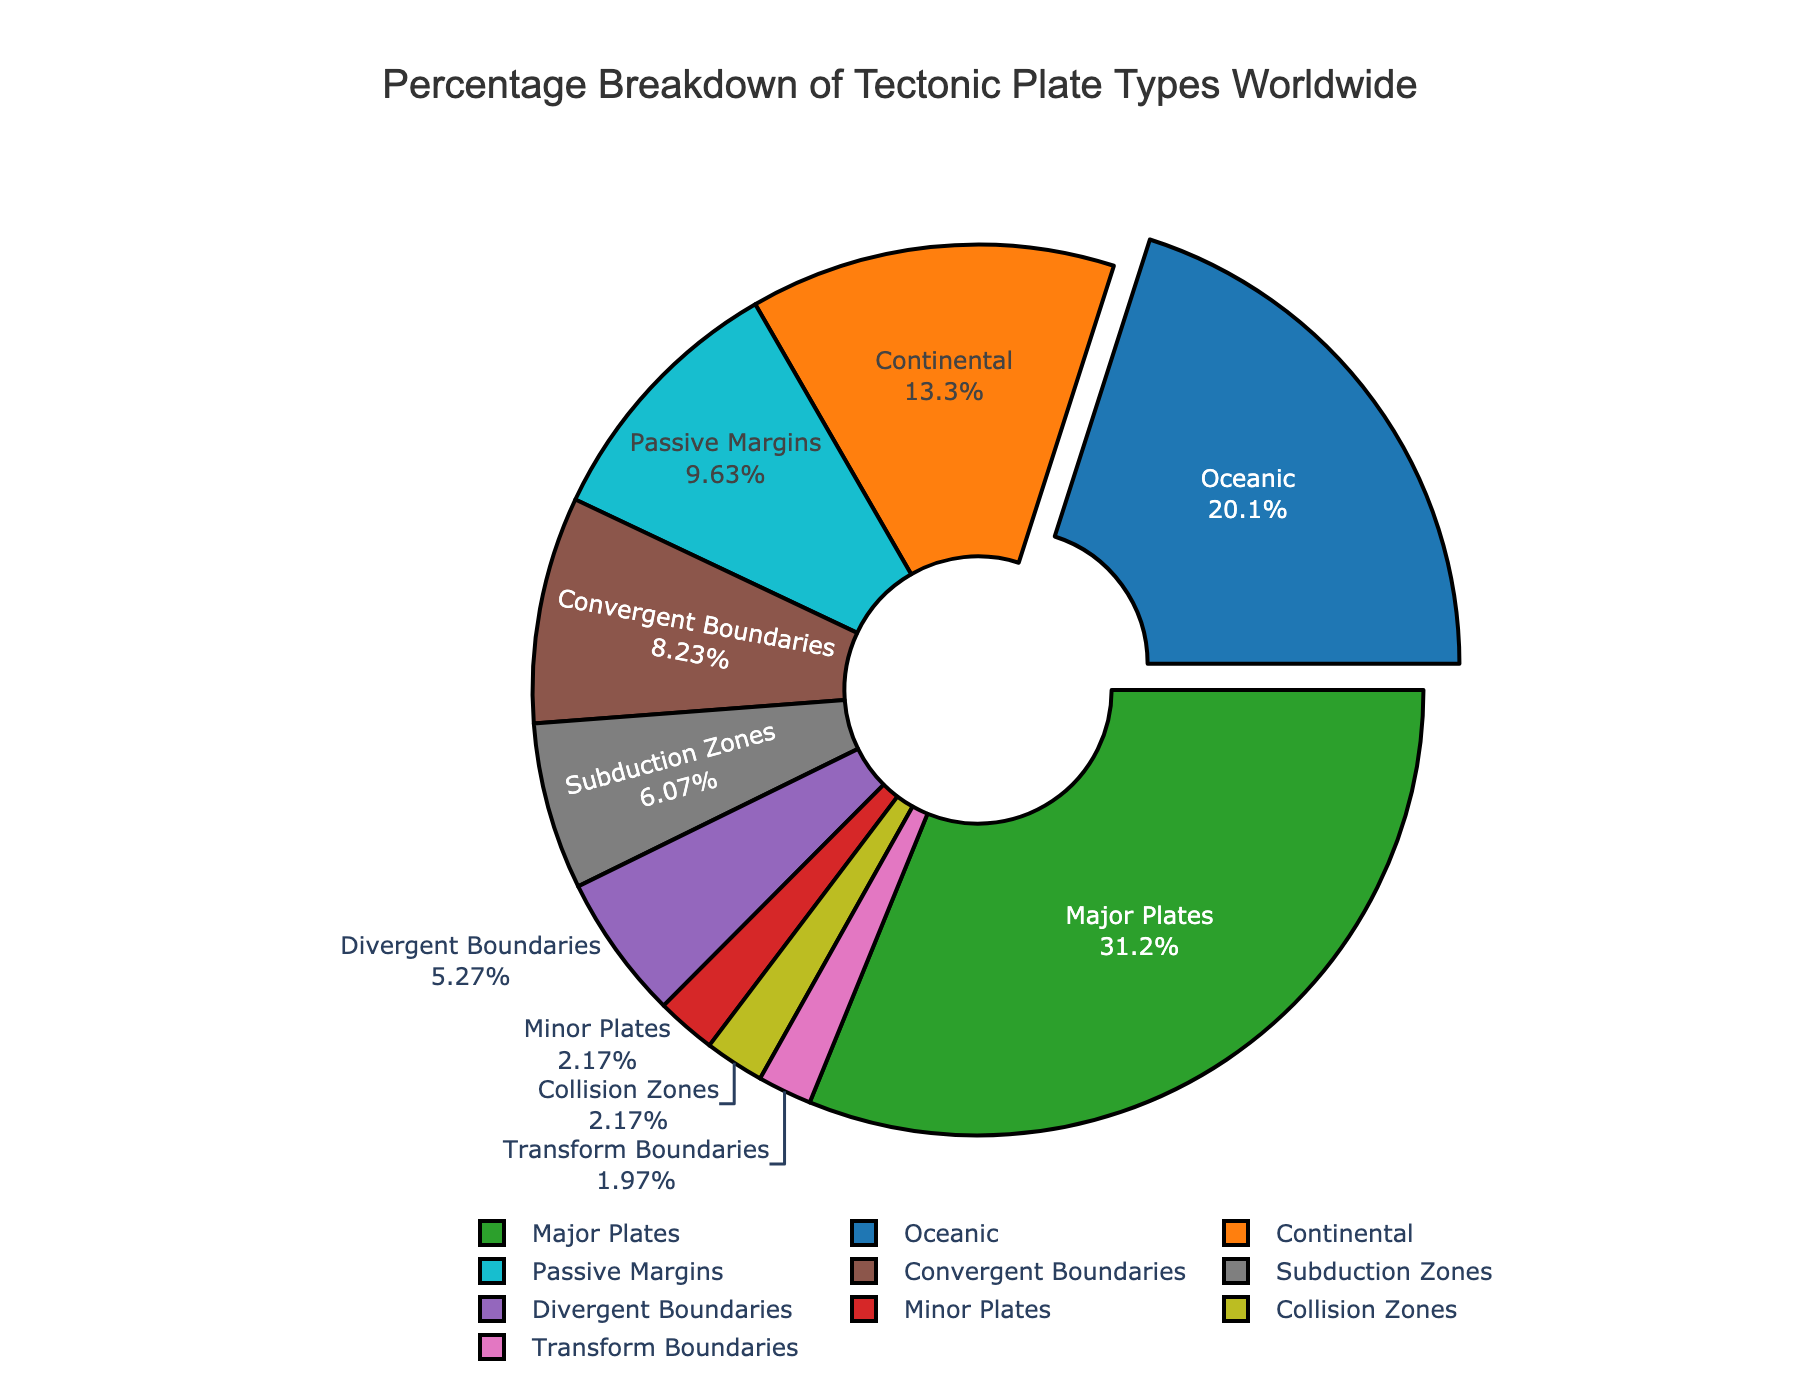What's the largest percentage category in the pie chart? The largest percentage category can be identified by looking at the slice that occupies the most area. From the data, "Oceanic" has the highest percentage at 60.2%.
Answer: Oceanic Which type accounts for less than 10% of the total? To determine this, examine the slices of the pie chart and spot the ones that are notably smaller. From the data, "Minor Plates" at 6.5% and "Transform Boundaries" at 5.9% are both below 10%.
Answer: Minor Plates, Transform Boundaries Compare the percentages of Divergent Boundaries and Convergent Boundaries. Which is more, and by how much? Check the two slices labeled "Divergent Boundaries" and "Convergent Boundaries." Divergent Boundaries account for 15.8%, while Convergent Boundaries account for 24.7%. Thus, Convergent Boundaries is greater by 24.7% - 15.8% = 8.9%.
Answer: Convergent Boundaries by 8.9% How do the percentages of Subduction Zones and Collision Zones add up? Add the percentages of the slices labeled "Subduction Zones" and "Collision Zones." Subduction Zones have 18.2% and Collision Zones have 6.5%, resulting in a sum of 18.2% + 6.5% = 24.7%.
Answer: 24.7% Identify all types that make up more than 20% each. To determine this, observe the slices and check their percentages. "Oceanic" at 60.2%, "Continental" at 39.8%, and "Major Plates" at 93.5% are the types above 20%.
Answer: Oceanic, Continental, Major Plates What's the combined percentage of types that are neither "Oceanic" nor "Continental"? Subtract the sum of "Oceanic" and "Continental" from 100%. Oceanic is 60.2% and Continental is 39.8%, so other types = 100% - (60.2% + 39.8%) = 100% - 100% = 0%. Thus, all described types are part of either Oceanic or Continental.
Answer: 0% Which has a higher percentage, Transform Boundaries or Passive Margins? Compare the slices for "Transform Boundaries" and "Passive Margins." Transform Boundaries have 5.9%, while Passive Margins have 28.9%.
Answer: Passive Margins What is the difference in percentage between Transform Boundaries and Collision Zones? Subtract the smaller percentage (Transform Boundaries at 5.9%) from the larger (Collision Zones at 6.5%). The difference is 6.5% - 5.9% = 0.6%.
Answer: 0.6% What's the total percentage of Divergent Boundaries, Convergent Boundaries, and Transform Boundaries combined? Sum the percentages for these slices. Divergent Boundaries are 15.8%, Convergent Boundaries are 24.7%, and Transform Boundaries are 5.9%. Adding them gives 15.8% + 24.7% + 5.9% = 46.4%.
Answer: 46.4% Which boundary type has the smallest percentage, and what is it? Identify the smallest slice in the boundary types. "Transform Boundaries" has the smallest percentage at 5.9%.
Answer: Transform Boundaries, 5.9% 